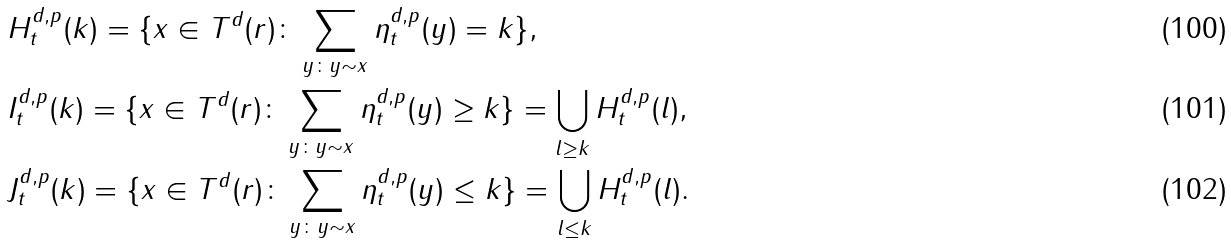Convert formula to latex. <formula><loc_0><loc_0><loc_500><loc_500>& H _ { t } ^ { d , p } ( k ) = \{ x \in T ^ { d } ( r ) \colon \sum _ { y \colon y \sim x } \eta _ { t } ^ { d , p } ( y ) = k \} , \\ & I _ { t } ^ { d , p } ( k ) = \{ x \in T ^ { d } ( r ) \colon \sum _ { y \colon y \sim x } \eta _ { t } ^ { d , p } ( y ) \geq k \} = \bigcup _ { l \geq k } H _ { t } ^ { d , p } ( l ) , \\ & J _ { t } ^ { d , p } ( k ) = \{ x \in T ^ { d } ( r ) \colon \sum _ { y \colon y \sim x } \eta _ { t } ^ { d , p } ( y ) \leq k \} = \bigcup _ { l \leq k } H _ { t } ^ { d , p } ( l ) .</formula> 